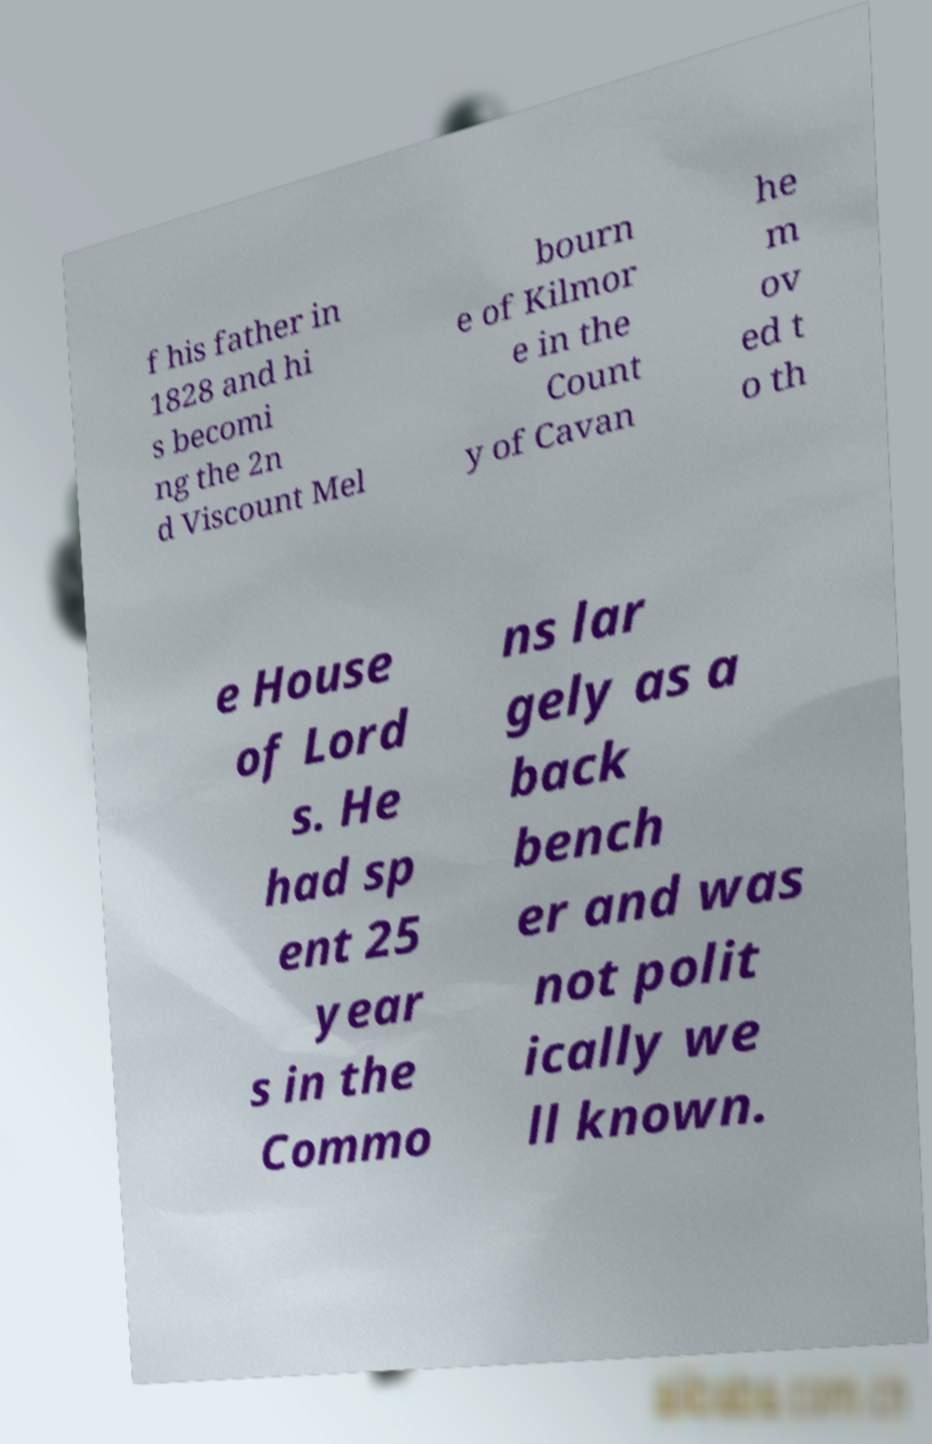There's text embedded in this image that I need extracted. Can you transcribe it verbatim? f his father in 1828 and hi s becomi ng the 2n d Viscount Mel bourn e of Kilmor e in the Count y of Cavan he m ov ed t o th e House of Lord s. He had sp ent 25 year s in the Commo ns lar gely as a back bench er and was not polit ically we ll known. 